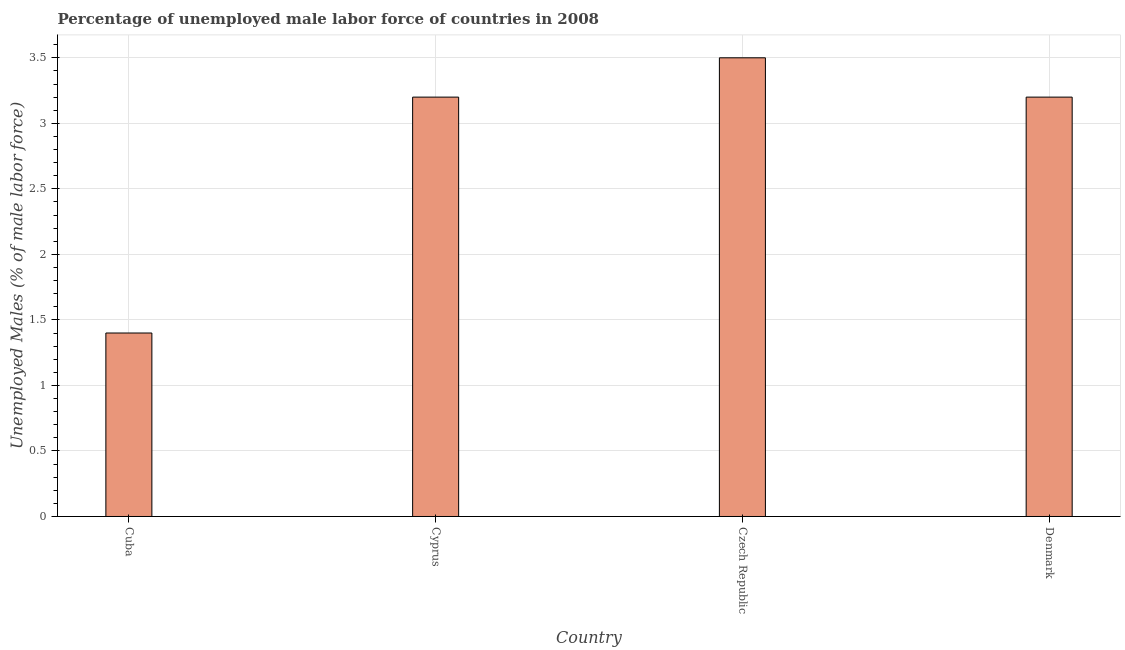Does the graph contain any zero values?
Provide a short and direct response. No. What is the title of the graph?
Offer a very short reply. Percentage of unemployed male labor force of countries in 2008. What is the label or title of the X-axis?
Your answer should be very brief. Country. What is the label or title of the Y-axis?
Your answer should be very brief. Unemployed Males (% of male labor force). What is the total unemployed male labour force in Denmark?
Provide a short and direct response. 3.2. Across all countries, what is the maximum total unemployed male labour force?
Offer a terse response. 3.5. Across all countries, what is the minimum total unemployed male labour force?
Make the answer very short. 1.4. In which country was the total unemployed male labour force maximum?
Provide a short and direct response. Czech Republic. In which country was the total unemployed male labour force minimum?
Provide a short and direct response. Cuba. What is the sum of the total unemployed male labour force?
Your answer should be very brief. 11.3. What is the average total unemployed male labour force per country?
Give a very brief answer. 2.83. What is the median total unemployed male labour force?
Keep it short and to the point. 3.2. What is the ratio of the total unemployed male labour force in Cyprus to that in Czech Republic?
Keep it short and to the point. 0.91. Is the difference between the total unemployed male labour force in Cuba and Czech Republic greater than the difference between any two countries?
Your response must be concise. Yes. Is the sum of the total unemployed male labour force in Cyprus and Denmark greater than the maximum total unemployed male labour force across all countries?
Offer a terse response. Yes. In how many countries, is the total unemployed male labour force greater than the average total unemployed male labour force taken over all countries?
Provide a short and direct response. 3. How many countries are there in the graph?
Offer a terse response. 4. What is the difference between two consecutive major ticks on the Y-axis?
Keep it short and to the point. 0.5. Are the values on the major ticks of Y-axis written in scientific E-notation?
Give a very brief answer. No. What is the Unemployed Males (% of male labor force) of Cuba?
Give a very brief answer. 1.4. What is the Unemployed Males (% of male labor force) of Cyprus?
Your answer should be very brief. 3.2. What is the Unemployed Males (% of male labor force) in Denmark?
Offer a very short reply. 3.2. What is the difference between the Unemployed Males (% of male labor force) in Cuba and Denmark?
Keep it short and to the point. -1.8. What is the difference between the Unemployed Males (% of male labor force) in Cyprus and Denmark?
Offer a very short reply. 0. What is the ratio of the Unemployed Males (% of male labor force) in Cuba to that in Cyprus?
Ensure brevity in your answer.  0.44. What is the ratio of the Unemployed Males (% of male labor force) in Cuba to that in Denmark?
Make the answer very short. 0.44. What is the ratio of the Unemployed Males (% of male labor force) in Cyprus to that in Czech Republic?
Ensure brevity in your answer.  0.91. What is the ratio of the Unemployed Males (% of male labor force) in Czech Republic to that in Denmark?
Ensure brevity in your answer.  1.09. 